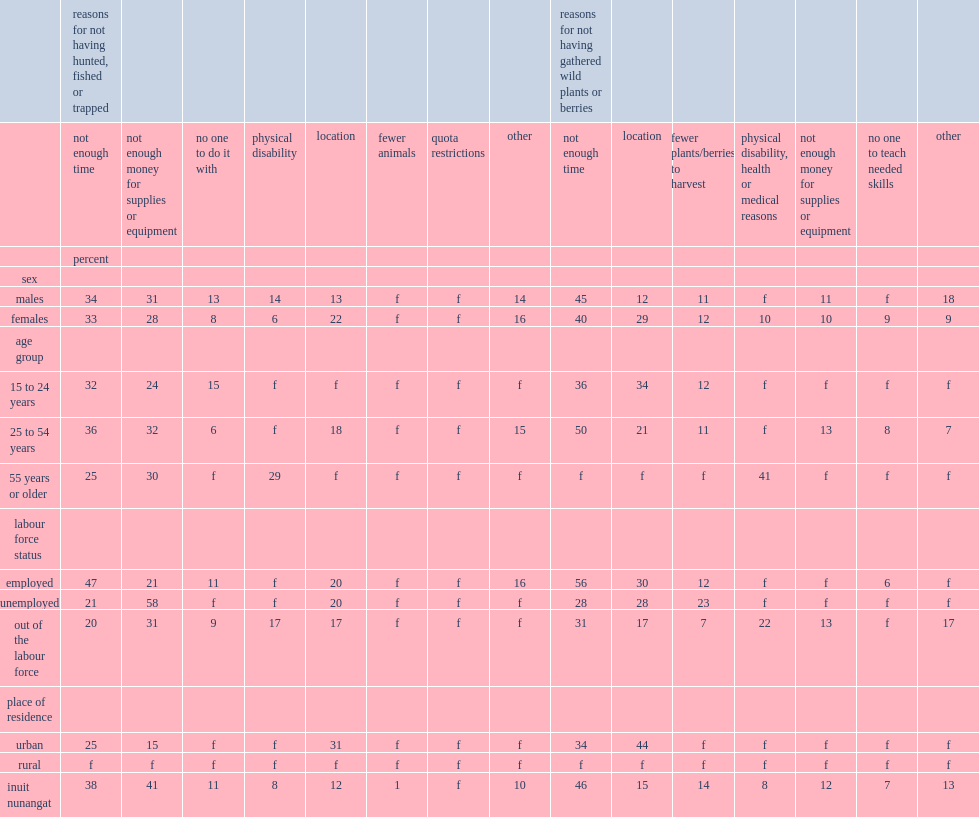What were the percentages of the leading reasons for not hunting, fishing or trapping were not having enough time among youth and young adults, and core working-age adults respectively? 32.0 36.0. What were the percentages of older inuit who were prevented from participating for time and monetary constraints respectively? 25.0 30.0. For gathering wild plants or berries, what were the percentages among youth and young adults and core working-age adults of not having enough time as the reason? 36.0 50.0. List the leading reason reported of not participating among older inuit. Physical disability, health or medical reasons. Can you parse all the data within this table? {'header': ['', 'reasons for not having hunted, fished or trapped', '', '', '', '', '', '', '', 'reasons for not having gathered wild plants or berries', '', '', '', '', '', ''], 'rows': [['', 'not enough time', 'not enough money for supplies or equipment', 'no one to do it with', 'physical disability', 'location', 'fewer animals', 'quota restrictions', 'other', 'not enough time', 'location', 'fewer plants/berries to harvest', 'physical disability, health or medical reasons', 'not enough money for supplies or equipment', 'no one to teach needed skills', 'other'], ['', 'percent', '', '', '', '', '', '', '', '', '', '', '', '', '', ''], ['sex', '', '', '', '', '', '', '', '', '', '', '', '', '', '', ''], ['males', '34', '31', '13', '14', '13', 'f', 'f', '14', '45', '12', '11', 'f', '11', 'f', '18'], ['females', '33', '28', '8', '6', '22', 'f', 'f', '16', '40', '29', '12', '10', '10', '9', '9'], ['age group', '', '', '', '', '', '', '', '', '', '', '', '', '', '', ''], ['15 to 24 years', '32', '24', '15', 'f', 'f', 'f', 'f', 'f', '36', '34', '12', 'f', 'f', 'f', 'f'], ['25 to 54 years', '36', '32', '6', 'f', '18', 'f', 'f', '15', '50', '21', '11', 'f', '13', '8', '7'], ['55 years or older', '25', '30', 'f', '29', 'f', 'f', 'f', 'f', 'f', 'f', 'f', '41', 'f', 'f', 'f'], ['labour force status', '', '', '', '', '', '', '', '', '', '', '', '', '', '', ''], ['employed', '47', '21', '11', 'f', '20', 'f', 'f', '16', '56', '30', '12', 'f', 'f', '6', 'f'], ['unemployed', '21', '58', 'f', 'f', '20', 'f', 'f', 'f', '28', '28', '23', 'f', 'f', 'f', 'f'], ['out of the labour force', '20', '31', '9', '17', '17', 'f', 'f', 'f', '31', '17', '7', '22', '13', 'f', '17'], ['place of residence', '', '', '', '', '', '', '', '', '', '', '', '', '', '', ''], ['urban', '25', '15', 'f', 'f', '31', 'f', 'f', 'f', '34', '44', 'f', 'f', 'f', 'f', 'f'], ['rural', 'f', 'f', 'f', 'f', 'f', 'f', 'f', 'f', 'f', 'f', 'f', 'f', 'f', 'f', 'f'], ['inuit nunangat', '38', '41', '11', '8', '12', '1', 'f', '10', '46', '15', '14', '8', '12', '7', '13']]} 